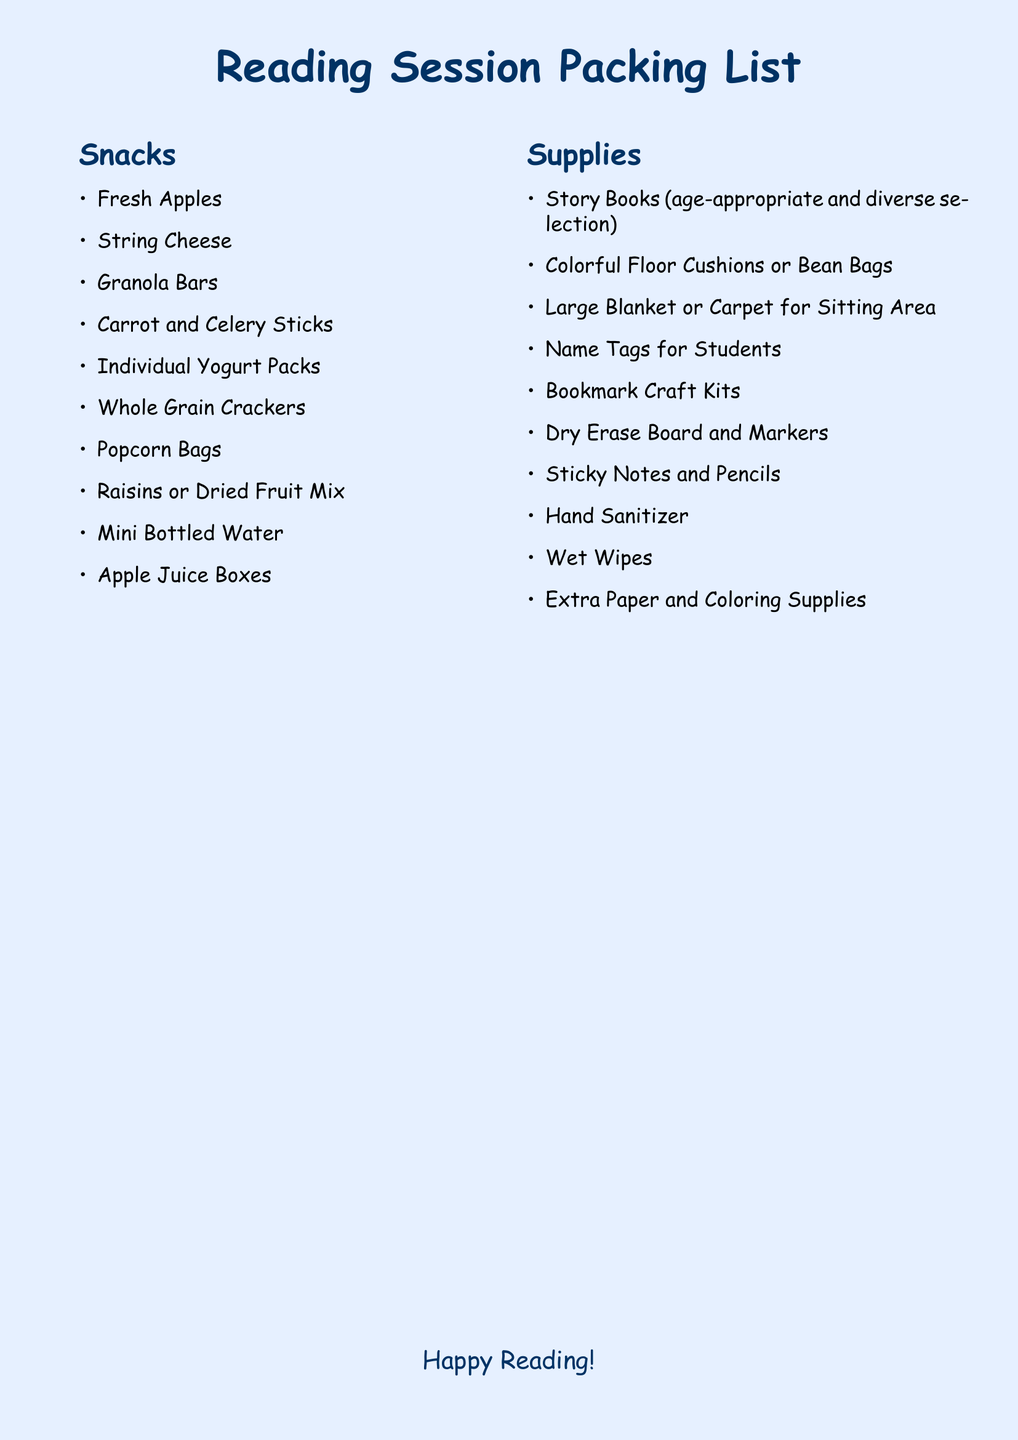what are two snack items listed? The document includes multiple snack items, and two examples can be taken from the list such as Apples and String Cheese.
Answer: Fresh Apples, String Cheese how many types of snacks are there? The document lists ten different snack items under the snacks category.
Answer: 10 what is one type of supply needed? The document specifies several supplies, any one of them can be mentioned, such as Story Books as a required supply.
Answer: Story Books which juice is included in the snacks? The document mentions Apple Juice Boxes as part of the snack items offered.
Answer: Apple Juice Boxes how many items are listed under supplies? The document outlines ten distinct supplies needed for the reading session.
Answer: 10 what should students have for sitting? The document suggests Colorful Floor Cushions or Bean Bags as seating options for students.
Answer: Colorful Floor Cushions or Bean Bags what crafting activity is mentioned? The document states that Bookmark Craft Kits are included as a crafting activity for students.
Answer: Bookmark Craft Kits is hand sanitizer a supplied item? The document includes Hand Sanitizer as one of the supplies needed for the event.
Answer: Yes what color is the document's background? The document has a background color specified as light blue.
Answer: Light Blue 